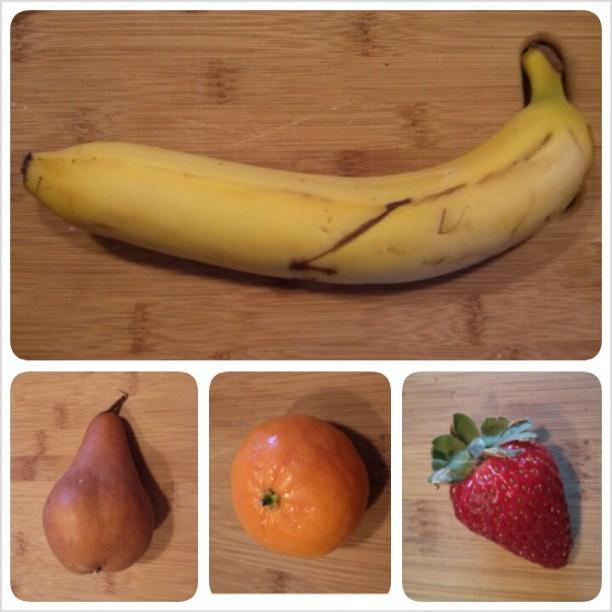How many fruits are present?
Be succinct. 4. What fruit is on the bottom right?
Quick response, please. Strawberry. How many of these need to be peeled before eating?
Keep it brief. 2. 